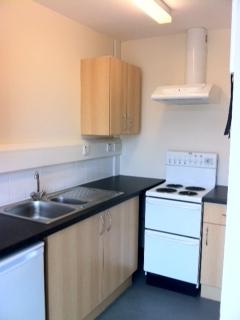Is the kitchen clean?
Keep it brief. Yes. Is the water running in the sink?
Short answer required. No. What kind of room is this?
Keep it brief. Kitchen. 